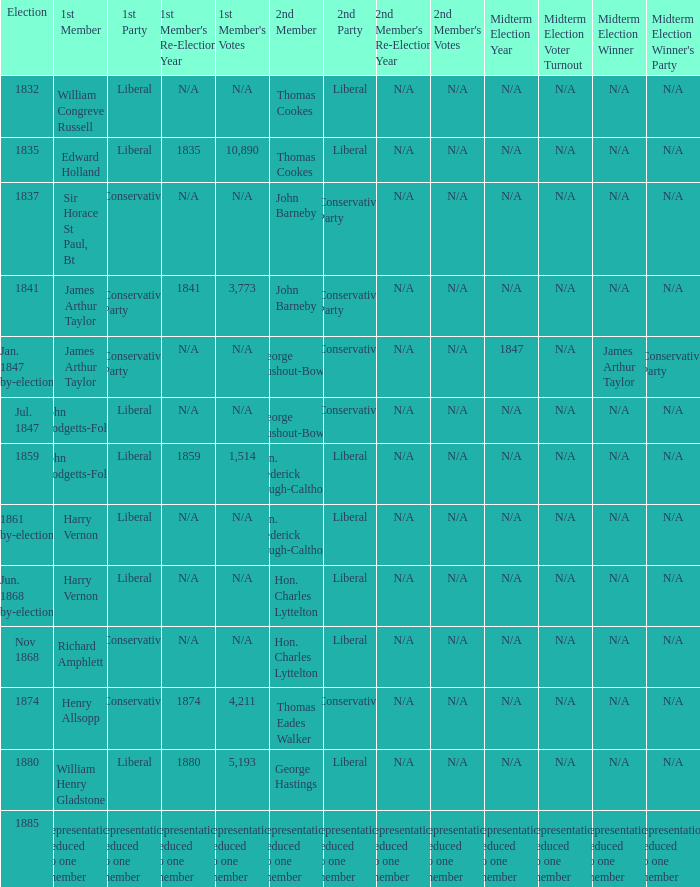What was the 1st Party when the 1st Member was William Congreve Russell? Liberal. 